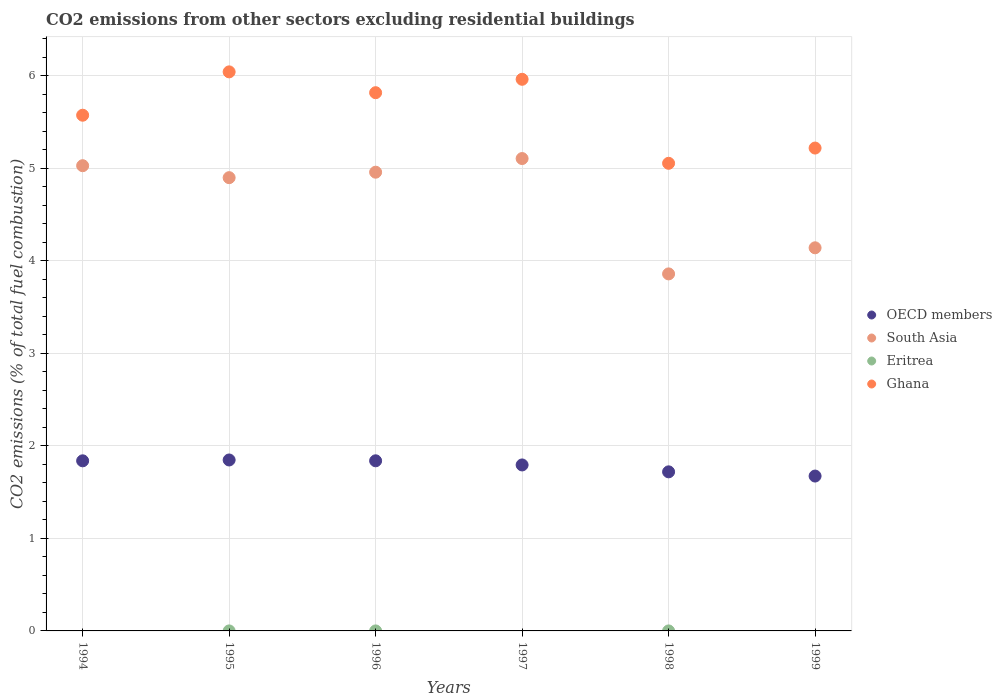Across all years, what is the maximum total CO2 emitted in South Asia?
Provide a short and direct response. 5.11. Across all years, what is the minimum total CO2 emitted in OECD members?
Offer a terse response. 1.67. What is the total total CO2 emitted in South Asia in the graph?
Offer a very short reply. 27.99. What is the difference between the total CO2 emitted in Ghana in 1997 and that in 1998?
Your answer should be very brief. 0.91. What is the difference between the total CO2 emitted in Ghana in 1995 and the total CO2 emitted in OECD members in 1996?
Offer a terse response. 4.2. What is the average total CO2 emitted in Ghana per year?
Ensure brevity in your answer.  5.61. In the year 1995, what is the difference between the total CO2 emitted in OECD members and total CO2 emitted in Eritrea?
Keep it short and to the point. 1.85. What is the ratio of the total CO2 emitted in OECD members in 1996 to that in 1997?
Your answer should be very brief. 1.02. Is the difference between the total CO2 emitted in OECD members in 1995 and 1998 greater than the difference between the total CO2 emitted in Eritrea in 1995 and 1998?
Ensure brevity in your answer.  Yes. What is the difference between the highest and the second highest total CO2 emitted in Ghana?
Your response must be concise. 0.08. What is the difference between the highest and the lowest total CO2 emitted in South Asia?
Your response must be concise. 1.25. Is it the case that in every year, the sum of the total CO2 emitted in Eritrea and total CO2 emitted in OECD members  is greater than the total CO2 emitted in Ghana?
Your answer should be compact. No. Does the total CO2 emitted in Eritrea monotonically increase over the years?
Offer a terse response. No. Is the total CO2 emitted in Eritrea strictly greater than the total CO2 emitted in Ghana over the years?
Your response must be concise. No. Is the total CO2 emitted in Eritrea strictly less than the total CO2 emitted in Ghana over the years?
Provide a short and direct response. Yes. What is the difference between two consecutive major ticks on the Y-axis?
Provide a short and direct response. 1. Are the values on the major ticks of Y-axis written in scientific E-notation?
Provide a succinct answer. No. Does the graph contain any zero values?
Ensure brevity in your answer.  Yes. What is the title of the graph?
Provide a short and direct response. CO2 emissions from other sectors excluding residential buildings. What is the label or title of the X-axis?
Your answer should be very brief. Years. What is the label or title of the Y-axis?
Keep it short and to the point. CO2 emissions (% of total fuel combustion). What is the CO2 emissions (% of total fuel combustion) of OECD members in 1994?
Provide a succinct answer. 1.84. What is the CO2 emissions (% of total fuel combustion) of South Asia in 1994?
Make the answer very short. 5.03. What is the CO2 emissions (% of total fuel combustion) of Ghana in 1994?
Your answer should be very brief. 5.57. What is the CO2 emissions (% of total fuel combustion) in OECD members in 1995?
Offer a very short reply. 1.85. What is the CO2 emissions (% of total fuel combustion) in South Asia in 1995?
Ensure brevity in your answer.  4.9. What is the CO2 emissions (% of total fuel combustion) of Eritrea in 1995?
Provide a succinct answer. 4.50577526227742e-16. What is the CO2 emissions (% of total fuel combustion) in Ghana in 1995?
Offer a very short reply. 6.04. What is the CO2 emissions (% of total fuel combustion) of OECD members in 1996?
Offer a terse response. 1.84. What is the CO2 emissions (% of total fuel combustion) of South Asia in 1996?
Your answer should be very brief. 4.96. What is the CO2 emissions (% of total fuel combustion) in Eritrea in 1996?
Your answer should be very brief. 0. What is the CO2 emissions (% of total fuel combustion) in Ghana in 1996?
Your answer should be very brief. 5.82. What is the CO2 emissions (% of total fuel combustion) in OECD members in 1997?
Ensure brevity in your answer.  1.79. What is the CO2 emissions (% of total fuel combustion) in South Asia in 1997?
Your answer should be compact. 5.11. What is the CO2 emissions (% of total fuel combustion) of Eritrea in 1997?
Your answer should be very brief. 0. What is the CO2 emissions (% of total fuel combustion) in Ghana in 1997?
Keep it short and to the point. 5.96. What is the CO2 emissions (% of total fuel combustion) of OECD members in 1998?
Keep it short and to the point. 1.72. What is the CO2 emissions (% of total fuel combustion) in South Asia in 1998?
Keep it short and to the point. 3.86. What is the CO2 emissions (% of total fuel combustion) of Eritrea in 1998?
Ensure brevity in your answer.  5.88041856263324e-16. What is the CO2 emissions (% of total fuel combustion) of Ghana in 1998?
Give a very brief answer. 5.05. What is the CO2 emissions (% of total fuel combustion) in OECD members in 1999?
Your response must be concise. 1.67. What is the CO2 emissions (% of total fuel combustion) of South Asia in 1999?
Offer a very short reply. 4.14. What is the CO2 emissions (% of total fuel combustion) in Ghana in 1999?
Ensure brevity in your answer.  5.22. Across all years, what is the maximum CO2 emissions (% of total fuel combustion) in OECD members?
Give a very brief answer. 1.85. Across all years, what is the maximum CO2 emissions (% of total fuel combustion) of South Asia?
Provide a succinct answer. 5.11. Across all years, what is the maximum CO2 emissions (% of total fuel combustion) of Eritrea?
Your answer should be very brief. 5.88041856263324e-16. Across all years, what is the maximum CO2 emissions (% of total fuel combustion) in Ghana?
Your answer should be compact. 6.04. Across all years, what is the minimum CO2 emissions (% of total fuel combustion) in OECD members?
Your response must be concise. 1.67. Across all years, what is the minimum CO2 emissions (% of total fuel combustion) of South Asia?
Give a very brief answer. 3.86. Across all years, what is the minimum CO2 emissions (% of total fuel combustion) of Ghana?
Offer a very short reply. 5.05. What is the total CO2 emissions (% of total fuel combustion) in OECD members in the graph?
Your answer should be compact. 10.71. What is the total CO2 emissions (% of total fuel combustion) of South Asia in the graph?
Provide a succinct answer. 27.99. What is the total CO2 emissions (% of total fuel combustion) in Ghana in the graph?
Offer a terse response. 33.67. What is the difference between the CO2 emissions (% of total fuel combustion) of OECD members in 1994 and that in 1995?
Provide a succinct answer. -0.01. What is the difference between the CO2 emissions (% of total fuel combustion) in South Asia in 1994 and that in 1995?
Your response must be concise. 0.13. What is the difference between the CO2 emissions (% of total fuel combustion) in Ghana in 1994 and that in 1995?
Make the answer very short. -0.47. What is the difference between the CO2 emissions (% of total fuel combustion) in OECD members in 1994 and that in 1996?
Your answer should be very brief. -0. What is the difference between the CO2 emissions (% of total fuel combustion) in South Asia in 1994 and that in 1996?
Offer a terse response. 0.07. What is the difference between the CO2 emissions (% of total fuel combustion) of Ghana in 1994 and that in 1996?
Provide a short and direct response. -0.24. What is the difference between the CO2 emissions (% of total fuel combustion) in OECD members in 1994 and that in 1997?
Provide a succinct answer. 0.04. What is the difference between the CO2 emissions (% of total fuel combustion) of South Asia in 1994 and that in 1997?
Your answer should be very brief. -0.08. What is the difference between the CO2 emissions (% of total fuel combustion) of Ghana in 1994 and that in 1997?
Offer a very short reply. -0.39. What is the difference between the CO2 emissions (% of total fuel combustion) of OECD members in 1994 and that in 1998?
Ensure brevity in your answer.  0.12. What is the difference between the CO2 emissions (% of total fuel combustion) in South Asia in 1994 and that in 1998?
Make the answer very short. 1.17. What is the difference between the CO2 emissions (% of total fuel combustion) of Ghana in 1994 and that in 1998?
Ensure brevity in your answer.  0.52. What is the difference between the CO2 emissions (% of total fuel combustion) of OECD members in 1994 and that in 1999?
Provide a short and direct response. 0.16. What is the difference between the CO2 emissions (% of total fuel combustion) of South Asia in 1994 and that in 1999?
Your answer should be compact. 0.89. What is the difference between the CO2 emissions (% of total fuel combustion) in Ghana in 1994 and that in 1999?
Provide a short and direct response. 0.35. What is the difference between the CO2 emissions (% of total fuel combustion) of OECD members in 1995 and that in 1996?
Your answer should be compact. 0.01. What is the difference between the CO2 emissions (% of total fuel combustion) in South Asia in 1995 and that in 1996?
Your answer should be very brief. -0.06. What is the difference between the CO2 emissions (% of total fuel combustion) of Ghana in 1995 and that in 1996?
Your answer should be very brief. 0.23. What is the difference between the CO2 emissions (% of total fuel combustion) of OECD members in 1995 and that in 1997?
Your answer should be compact. 0.05. What is the difference between the CO2 emissions (% of total fuel combustion) of South Asia in 1995 and that in 1997?
Keep it short and to the point. -0.21. What is the difference between the CO2 emissions (% of total fuel combustion) of Ghana in 1995 and that in 1997?
Give a very brief answer. 0.08. What is the difference between the CO2 emissions (% of total fuel combustion) in OECD members in 1995 and that in 1998?
Offer a very short reply. 0.13. What is the difference between the CO2 emissions (% of total fuel combustion) of South Asia in 1995 and that in 1998?
Offer a very short reply. 1.04. What is the difference between the CO2 emissions (% of total fuel combustion) of Eritrea in 1995 and that in 1998?
Give a very brief answer. -0. What is the difference between the CO2 emissions (% of total fuel combustion) of OECD members in 1995 and that in 1999?
Make the answer very short. 0.17. What is the difference between the CO2 emissions (% of total fuel combustion) in South Asia in 1995 and that in 1999?
Offer a very short reply. 0.76. What is the difference between the CO2 emissions (% of total fuel combustion) in Ghana in 1995 and that in 1999?
Ensure brevity in your answer.  0.82. What is the difference between the CO2 emissions (% of total fuel combustion) of OECD members in 1996 and that in 1997?
Provide a short and direct response. 0.04. What is the difference between the CO2 emissions (% of total fuel combustion) in South Asia in 1996 and that in 1997?
Make the answer very short. -0.15. What is the difference between the CO2 emissions (% of total fuel combustion) in Ghana in 1996 and that in 1997?
Keep it short and to the point. -0.14. What is the difference between the CO2 emissions (% of total fuel combustion) in OECD members in 1996 and that in 1998?
Your answer should be very brief. 0.12. What is the difference between the CO2 emissions (% of total fuel combustion) in South Asia in 1996 and that in 1998?
Keep it short and to the point. 1.1. What is the difference between the CO2 emissions (% of total fuel combustion) of Ghana in 1996 and that in 1998?
Make the answer very short. 0.76. What is the difference between the CO2 emissions (% of total fuel combustion) of OECD members in 1996 and that in 1999?
Offer a terse response. 0.16. What is the difference between the CO2 emissions (% of total fuel combustion) of South Asia in 1996 and that in 1999?
Offer a very short reply. 0.82. What is the difference between the CO2 emissions (% of total fuel combustion) of Ghana in 1996 and that in 1999?
Give a very brief answer. 0.6. What is the difference between the CO2 emissions (% of total fuel combustion) in OECD members in 1997 and that in 1998?
Your answer should be very brief. 0.07. What is the difference between the CO2 emissions (% of total fuel combustion) of South Asia in 1997 and that in 1998?
Provide a short and direct response. 1.25. What is the difference between the CO2 emissions (% of total fuel combustion) in Ghana in 1997 and that in 1998?
Keep it short and to the point. 0.91. What is the difference between the CO2 emissions (% of total fuel combustion) in OECD members in 1997 and that in 1999?
Give a very brief answer. 0.12. What is the difference between the CO2 emissions (% of total fuel combustion) of South Asia in 1997 and that in 1999?
Make the answer very short. 0.96. What is the difference between the CO2 emissions (% of total fuel combustion) in Ghana in 1997 and that in 1999?
Give a very brief answer. 0.74. What is the difference between the CO2 emissions (% of total fuel combustion) of OECD members in 1998 and that in 1999?
Provide a succinct answer. 0.05. What is the difference between the CO2 emissions (% of total fuel combustion) in South Asia in 1998 and that in 1999?
Give a very brief answer. -0.28. What is the difference between the CO2 emissions (% of total fuel combustion) of Ghana in 1998 and that in 1999?
Your response must be concise. -0.16. What is the difference between the CO2 emissions (% of total fuel combustion) of OECD members in 1994 and the CO2 emissions (% of total fuel combustion) of South Asia in 1995?
Offer a very short reply. -3.06. What is the difference between the CO2 emissions (% of total fuel combustion) in OECD members in 1994 and the CO2 emissions (% of total fuel combustion) in Eritrea in 1995?
Make the answer very short. 1.84. What is the difference between the CO2 emissions (% of total fuel combustion) of OECD members in 1994 and the CO2 emissions (% of total fuel combustion) of Ghana in 1995?
Offer a very short reply. -4.2. What is the difference between the CO2 emissions (% of total fuel combustion) of South Asia in 1994 and the CO2 emissions (% of total fuel combustion) of Eritrea in 1995?
Offer a terse response. 5.03. What is the difference between the CO2 emissions (% of total fuel combustion) in South Asia in 1994 and the CO2 emissions (% of total fuel combustion) in Ghana in 1995?
Your response must be concise. -1.01. What is the difference between the CO2 emissions (% of total fuel combustion) of OECD members in 1994 and the CO2 emissions (% of total fuel combustion) of South Asia in 1996?
Your answer should be very brief. -3.12. What is the difference between the CO2 emissions (% of total fuel combustion) in OECD members in 1994 and the CO2 emissions (% of total fuel combustion) in Ghana in 1996?
Give a very brief answer. -3.98. What is the difference between the CO2 emissions (% of total fuel combustion) in South Asia in 1994 and the CO2 emissions (% of total fuel combustion) in Ghana in 1996?
Your answer should be compact. -0.79. What is the difference between the CO2 emissions (% of total fuel combustion) of OECD members in 1994 and the CO2 emissions (% of total fuel combustion) of South Asia in 1997?
Provide a succinct answer. -3.27. What is the difference between the CO2 emissions (% of total fuel combustion) in OECD members in 1994 and the CO2 emissions (% of total fuel combustion) in Ghana in 1997?
Your response must be concise. -4.12. What is the difference between the CO2 emissions (% of total fuel combustion) in South Asia in 1994 and the CO2 emissions (% of total fuel combustion) in Ghana in 1997?
Your answer should be compact. -0.93. What is the difference between the CO2 emissions (% of total fuel combustion) of OECD members in 1994 and the CO2 emissions (% of total fuel combustion) of South Asia in 1998?
Make the answer very short. -2.02. What is the difference between the CO2 emissions (% of total fuel combustion) of OECD members in 1994 and the CO2 emissions (% of total fuel combustion) of Eritrea in 1998?
Ensure brevity in your answer.  1.84. What is the difference between the CO2 emissions (% of total fuel combustion) of OECD members in 1994 and the CO2 emissions (% of total fuel combustion) of Ghana in 1998?
Your answer should be very brief. -3.22. What is the difference between the CO2 emissions (% of total fuel combustion) of South Asia in 1994 and the CO2 emissions (% of total fuel combustion) of Eritrea in 1998?
Your answer should be compact. 5.03. What is the difference between the CO2 emissions (% of total fuel combustion) in South Asia in 1994 and the CO2 emissions (% of total fuel combustion) in Ghana in 1998?
Your answer should be very brief. -0.03. What is the difference between the CO2 emissions (% of total fuel combustion) of OECD members in 1994 and the CO2 emissions (% of total fuel combustion) of South Asia in 1999?
Your answer should be compact. -2.3. What is the difference between the CO2 emissions (% of total fuel combustion) of OECD members in 1994 and the CO2 emissions (% of total fuel combustion) of Ghana in 1999?
Offer a terse response. -3.38. What is the difference between the CO2 emissions (% of total fuel combustion) of South Asia in 1994 and the CO2 emissions (% of total fuel combustion) of Ghana in 1999?
Make the answer very short. -0.19. What is the difference between the CO2 emissions (% of total fuel combustion) in OECD members in 1995 and the CO2 emissions (% of total fuel combustion) in South Asia in 1996?
Provide a succinct answer. -3.11. What is the difference between the CO2 emissions (% of total fuel combustion) in OECD members in 1995 and the CO2 emissions (% of total fuel combustion) in Ghana in 1996?
Provide a succinct answer. -3.97. What is the difference between the CO2 emissions (% of total fuel combustion) in South Asia in 1995 and the CO2 emissions (% of total fuel combustion) in Ghana in 1996?
Offer a very short reply. -0.92. What is the difference between the CO2 emissions (% of total fuel combustion) of Eritrea in 1995 and the CO2 emissions (% of total fuel combustion) of Ghana in 1996?
Your answer should be compact. -5.82. What is the difference between the CO2 emissions (% of total fuel combustion) of OECD members in 1995 and the CO2 emissions (% of total fuel combustion) of South Asia in 1997?
Your answer should be very brief. -3.26. What is the difference between the CO2 emissions (% of total fuel combustion) in OECD members in 1995 and the CO2 emissions (% of total fuel combustion) in Ghana in 1997?
Ensure brevity in your answer.  -4.11. What is the difference between the CO2 emissions (% of total fuel combustion) in South Asia in 1995 and the CO2 emissions (% of total fuel combustion) in Ghana in 1997?
Make the answer very short. -1.06. What is the difference between the CO2 emissions (% of total fuel combustion) of Eritrea in 1995 and the CO2 emissions (% of total fuel combustion) of Ghana in 1997?
Your response must be concise. -5.96. What is the difference between the CO2 emissions (% of total fuel combustion) in OECD members in 1995 and the CO2 emissions (% of total fuel combustion) in South Asia in 1998?
Give a very brief answer. -2.01. What is the difference between the CO2 emissions (% of total fuel combustion) in OECD members in 1995 and the CO2 emissions (% of total fuel combustion) in Eritrea in 1998?
Give a very brief answer. 1.85. What is the difference between the CO2 emissions (% of total fuel combustion) in OECD members in 1995 and the CO2 emissions (% of total fuel combustion) in Ghana in 1998?
Ensure brevity in your answer.  -3.21. What is the difference between the CO2 emissions (% of total fuel combustion) of South Asia in 1995 and the CO2 emissions (% of total fuel combustion) of Eritrea in 1998?
Your answer should be compact. 4.9. What is the difference between the CO2 emissions (% of total fuel combustion) in South Asia in 1995 and the CO2 emissions (% of total fuel combustion) in Ghana in 1998?
Offer a very short reply. -0.16. What is the difference between the CO2 emissions (% of total fuel combustion) in Eritrea in 1995 and the CO2 emissions (% of total fuel combustion) in Ghana in 1998?
Offer a terse response. -5.05. What is the difference between the CO2 emissions (% of total fuel combustion) of OECD members in 1995 and the CO2 emissions (% of total fuel combustion) of South Asia in 1999?
Offer a very short reply. -2.29. What is the difference between the CO2 emissions (% of total fuel combustion) of OECD members in 1995 and the CO2 emissions (% of total fuel combustion) of Ghana in 1999?
Keep it short and to the point. -3.37. What is the difference between the CO2 emissions (% of total fuel combustion) in South Asia in 1995 and the CO2 emissions (% of total fuel combustion) in Ghana in 1999?
Keep it short and to the point. -0.32. What is the difference between the CO2 emissions (% of total fuel combustion) in Eritrea in 1995 and the CO2 emissions (% of total fuel combustion) in Ghana in 1999?
Provide a succinct answer. -5.22. What is the difference between the CO2 emissions (% of total fuel combustion) in OECD members in 1996 and the CO2 emissions (% of total fuel combustion) in South Asia in 1997?
Offer a terse response. -3.27. What is the difference between the CO2 emissions (% of total fuel combustion) in OECD members in 1996 and the CO2 emissions (% of total fuel combustion) in Ghana in 1997?
Your response must be concise. -4.12. What is the difference between the CO2 emissions (% of total fuel combustion) in South Asia in 1996 and the CO2 emissions (% of total fuel combustion) in Ghana in 1997?
Give a very brief answer. -1. What is the difference between the CO2 emissions (% of total fuel combustion) of OECD members in 1996 and the CO2 emissions (% of total fuel combustion) of South Asia in 1998?
Keep it short and to the point. -2.02. What is the difference between the CO2 emissions (% of total fuel combustion) in OECD members in 1996 and the CO2 emissions (% of total fuel combustion) in Eritrea in 1998?
Provide a short and direct response. 1.84. What is the difference between the CO2 emissions (% of total fuel combustion) in OECD members in 1996 and the CO2 emissions (% of total fuel combustion) in Ghana in 1998?
Ensure brevity in your answer.  -3.22. What is the difference between the CO2 emissions (% of total fuel combustion) in South Asia in 1996 and the CO2 emissions (% of total fuel combustion) in Eritrea in 1998?
Your answer should be very brief. 4.96. What is the difference between the CO2 emissions (% of total fuel combustion) in South Asia in 1996 and the CO2 emissions (% of total fuel combustion) in Ghana in 1998?
Ensure brevity in your answer.  -0.1. What is the difference between the CO2 emissions (% of total fuel combustion) of OECD members in 1996 and the CO2 emissions (% of total fuel combustion) of South Asia in 1999?
Your answer should be very brief. -2.3. What is the difference between the CO2 emissions (% of total fuel combustion) in OECD members in 1996 and the CO2 emissions (% of total fuel combustion) in Ghana in 1999?
Ensure brevity in your answer.  -3.38. What is the difference between the CO2 emissions (% of total fuel combustion) of South Asia in 1996 and the CO2 emissions (% of total fuel combustion) of Ghana in 1999?
Make the answer very short. -0.26. What is the difference between the CO2 emissions (% of total fuel combustion) in OECD members in 1997 and the CO2 emissions (% of total fuel combustion) in South Asia in 1998?
Your answer should be very brief. -2.06. What is the difference between the CO2 emissions (% of total fuel combustion) of OECD members in 1997 and the CO2 emissions (% of total fuel combustion) of Eritrea in 1998?
Keep it short and to the point. 1.79. What is the difference between the CO2 emissions (% of total fuel combustion) of OECD members in 1997 and the CO2 emissions (% of total fuel combustion) of Ghana in 1998?
Your response must be concise. -3.26. What is the difference between the CO2 emissions (% of total fuel combustion) of South Asia in 1997 and the CO2 emissions (% of total fuel combustion) of Eritrea in 1998?
Your answer should be compact. 5.11. What is the difference between the CO2 emissions (% of total fuel combustion) in South Asia in 1997 and the CO2 emissions (% of total fuel combustion) in Ghana in 1998?
Your answer should be compact. 0.05. What is the difference between the CO2 emissions (% of total fuel combustion) of OECD members in 1997 and the CO2 emissions (% of total fuel combustion) of South Asia in 1999?
Provide a short and direct response. -2.35. What is the difference between the CO2 emissions (% of total fuel combustion) of OECD members in 1997 and the CO2 emissions (% of total fuel combustion) of Ghana in 1999?
Provide a succinct answer. -3.42. What is the difference between the CO2 emissions (% of total fuel combustion) of South Asia in 1997 and the CO2 emissions (% of total fuel combustion) of Ghana in 1999?
Your answer should be compact. -0.11. What is the difference between the CO2 emissions (% of total fuel combustion) in OECD members in 1998 and the CO2 emissions (% of total fuel combustion) in South Asia in 1999?
Provide a succinct answer. -2.42. What is the difference between the CO2 emissions (% of total fuel combustion) of OECD members in 1998 and the CO2 emissions (% of total fuel combustion) of Ghana in 1999?
Provide a short and direct response. -3.5. What is the difference between the CO2 emissions (% of total fuel combustion) in South Asia in 1998 and the CO2 emissions (% of total fuel combustion) in Ghana in 1999?
Your answer should be compact. -1.36. What is the difference between the CO2 emissions (% of total fuel combustion) of Eritrea in 1998 and the CO2 emissions (% of total fuel combustion) of Ghana in 1999?
Give a very brief answer. -5.22. What is the average CO2 emissions (% of total fuel combustion) of OECD members per year?
Make the answer very short. 1.79. What is the average CO2 emissions (% of total fuel combustion) of South Asia per year?
Keep it short and to the point. 4.67. What is the average CO2 emissions (% of total fuel combustion) in Ghana per year?
Keep it short and to the point. 5.61. In the year 1994, what is the difference between the CO2 emissions (% of total fuel combustion) in OECD members and CO2 emissions (% of total fuel combustion) in South Asia?
Your answer should be compact. -3.19. In the year 1994, what is the difference between the CO2 emissions (% of total fuel combustion) in OECD members and CO2 emissions (% of total fuel combustion) in Ghana?
Your answer should be very brief. -3.74. In the year 1994, what is the difference between the CO2 emissions (% of total fuel combustion) of South Asia and CO2 emissions (% of total fuel combustion) of Ghana?
Keep it short and to the point. -0.55. In the year 1995, what is the difference between the CO2 emissions (% of total fuel combustion) in OECD members and CO2 emissions (% of total fuel combustion) in South Asia?
Ensure brevity in your answer.  -3.05. In the year 1995, what is the difference between the CO2 emissions (% of total fuel combustion) of OECD members and CO2 emissions (% of total fuel combustion) of Eritrea?
Make the answer very short. 1.85. In the year 1995, what is the difference between the CO2 emissions (% of total fuel combustion) of OECD members and CO2 emissions (% of total fuel combustion) of Ghana?
Keep it short and to the point. -4.19. In the year 1995, what is the difference between the CO2 emissions (% of total fuel combustion) of South Asia and CO2 emissions (% of total fuel combustion) of Eritrea?
Ensure brevity in your answer.  4.9. In the year 1995, what is the difference between the CO2 emissions (% of total fuel combustion) in South Asia and CO2 emissions (% of total fuel combustion) in Ghana?
Your response must be concise. -1.14. In the year 1995, what is the difference between the CO2 emissions (% of total fuel combustion) in Eritrea and CO2 emissions (% of total fuel combustion) in Ghana?
Ensure brevity in your answer.  -6.04. In the year 1996, what is the difference between the CO2 emissions (% of total fuel combustion) of OECD members and CO2 emissions (% of total fuel combustion) of South Asia?
Give a very brief answer. -3.12. In the year 1996, what is the difference between the CO2 emissions (% of total fuel combustion) of OECD members and CO2 emissions (% of total fuel combustion) of Ghana?
Ensure brevity in your answer.  -3.98. In the year 1996, what is the difference between the CO2 emissions (% of total fuel combustion) in South Asia and CO2 emissions (% of total fuel combustion) in Ghana?
Keep it short and to the point. -0.86. In the year 1997, what is the difference between the CO2 emissions (% of total fuel combustion) in OECD members and CO2 emissions (% of total fuel combustion) in South Asia?
Offer a terse response. -3.31. In the year 1997, what is the difference between the CO2 emissions (% of total fuel combustion) in OECD members and CO2 emissions (% of total fuel combustion) in Ghana?
Provide a short and direct response. -4.17. In the year 1997, what is the difference between the CO2 emissions (% of total fuel combustion) of South Asia and CO2 emissions (% of total fuel combustion) of Ghana?
Your response must be concise. -0.86. In the year 1998, what is the difference between the CO2 emissions (% of total fuel combustion) in OECD members and CO2 emissions (% of total fuel combustion) in South Asia?
Offer a terse response. -2.14. In the year 1998, what is the difference between the CO2 emissions (% of total fuel combustion) in OECD members and CO2 emissions (% of total fuel combustion) in Eritrea?
Provide a short and direct response. 1.72. In the year 1998, what is the difference between the CO2 emissions (% of total fuel combustion) in OECD members and CO2 emissions (% of total fuel combustion) in Ghana?
Ensure brevity in your answer.  -3.33. In the year 1998, what is the difference between the CO2 emissions (% of total fuel combustion) of South Asia and CO2 emissions (% of total fuel combustion) of Eritrea?
Offer a terse response. 3.86. In the year 1998, what is the difference between the CO2 emissions (% of total fuel combustion) in South Asia and CO2 emissions (% of total fuel combustion) in Ghana?
Provide a short and direct response. -1.2. In the year 1998, what is the difference between the CO2 emissions (% of total fuel combustion) in Eritrea and CO2 emissions (% of total fuel combustion) in Ghana?
Your answer should be very brief. -5.05. In the year 1999, what is the difference between the CO2 emissions (% of total fuel combustion) of OECD members and CO2 emissions (% of total fuel combustion) of South Asia?
Provide a short and direct response. -2.47. In the year 1999, what is the difference between the CO2 emissions (% of total fuel combustion) of OECD members and CO2 emissions (% of total fuel combustion) of Ghana?
Your response must be concise. -3.54. In the year 1999, what is the difference between the CO2 emissions (% of total fuel combustion) in South Asia and CO2 emissions (% of total fuel combustion) in Ghana?
Keep it short and to the point. -1.08. What is the ratio of the CO2 emissions (% of total fuel combustion) of South Asia in 1994 to that in 1995?
Keep it short and to the point. 1.03. What is the ratio of the CO2 emissions (% of total fuel combustion) of Ghana in 1994 to that in 1995?
Ensure brevity in your answer.  0.92. What is the ratio of the CO2 emissions (% of total fuel combustion) of OECD members in 1994 to that in 1996?
Give a very brief answer. 1. What is the ratio of the CO2 emissions (% of total fuel combustion) of South Asia in 1994 to that in 1996?
Your response must be concise. 1.01. What is the ratio of the CO2 emissions (% of total fuel combustion) of Ghana in 1994 to that in 1996?
Offer a very short reply. 0.96. What is the ratio of the CO2 emissions (% of total fuel combustion) in OECD members in 1994 to that in 1997?
Offer a very short reply. 1.02. What is the ratio of the CO2 emissions (% of total fuel combustion) in South Asia in 1994 to that in 1997?
Provide a succinct answer. 0.98. What is the ratio of the CO2 emissions (% of total fuel combustion) in Ghana in 1994 to that in 1997?
Your answer should be compact. 0.93. What is the ratio of the CO2 emissions (% of total fuel combustion) in OECD members in 1994 to that in 1998?
Give a very brief answer. 1.07. What is the ratio of the CO2 emissions (% of total fuel combustion) of South Asia in 1994 to that in 1998?
Your answer should be very brief. 1.3. What is the ratio of the CO2 emissions (% of total fuel combustion) in Ghana in 1994 to that in 1998?
Ensure brevity in your answer.  1.1. What is the ratio of the CO2 emissions (% of total fuel combustion) of OECD members in 1994 to that in 1999?
Make the answer very short. 1.1. What is the ratio of the CO2 emissions (% of total fuel combustion) of South Asia in 1994 to that in 1999?
Your response must be concise. 1.21. What is the ratio of the CO2 emissions (% of total fuel combustion) in Ghana in 1994 to that in 1999?
Provide a short and direct response. 1.07. What is the ratio of the CO2 emissions (% of total fuel combustion) in OECD members in 1995 to that in 1996?
Provide a short and direct response. 1. What is the ratio of the CO2 emissions (% of total fuel combustion) in South Asia in 1995 to that in 1996?
Offer a terse response. 0.99. What is the ratio of the CO2 emissions (% of total fuel combustion) of Ghana in 1995 to that in 1996?
Your response must be concise. 1.04. What is the ratio of the CO2 emissions (% of total fuel combustion) of OECD members in 1995 to that in 1997?
Offer a very short reply. 1.03. What is the ratio of the CO2 emissions (% of total fuel combustion) in South Asia in 1995 to that in 1997?
Make the answer very short. 0.96. What is the ratio of the CO2 emissions (% of total fuel combustion) of Ghana in 1995 to that in 1997?
Your response must be concise. 1.01. What is the ratio of the CO2 emissions (% of total fuel combustion) of OECD members in 1995 to that in 1998?
Keep it short and to the point. 1.07. What is the ratio of the CO2 emissions (% of total fuel combustion) of South Asia in 1995 to that in 1998?
Provide a succinct answer. 1.27. What is the ratio of the CO2 emissions (% of total fuel combustion) in Eritrea in 1995 to that in 1998?
Your answer should be very brief. 0.77. What is the ratio of the CO2 emissions (% of total fuel combustion) of Ghana in 1995 to that in 1998?
Your answer should be compact. 1.2. What is the ratio of the CO2 emissions (% of total fuel combustion) in OECD members in 1995 to that in 1999?
Give a very brief answer. 1.1. What is the ratio of the CO2 emissions (% of total fuel combustion) of South Asia in 1995 to that in 1999?
Keep it short and to the point. 1.18. What is the ratio of the CO2 emissions (% of total fuel combustion) in Ghana in 1995 to that in 1999?
Your answer should be very brief. 1.16. What is the ratio of the CO2 emissions (% of total fuel combustion) in OECD members in 1996 to that in 1997?
Keep it short and to the point. 1.02. What is the ratio of the CO2 emissions (% of total fuel combustion) in South Asia in 1996 to that in 1997?
Your answer should be compact. 0.97. What is the ratio of the CO2 emissions (% of total fuel combustion) of Ghana in 1996 to that in 1997?
Provide a succinct answer. 0.98. What is the ratio of the CO2 emissions (% of total fuel combustion) of OECD members in 1996 to that in 1998?
Offer a very short reply. 1.07. What is the ratio of the CO2 emissions (% of total fuel combustion) of South Asia in 1996 to that in 1998?
Make the answer very short. 1.28. What is the ratio of the CO2 emissions (% of total fuel combustion) of Ghana in 1996 to that in 1998?
Offer a terse response. 1.15. What is the ratio of the CO2 emissions (% of total fuel combustion) of OECD members in 1996 to that in 1999?
Give a very brief answer. 1.1. What is the ratio of the CO2 emissions (% of total fuel combustion) of South Asia in 1996 to that in 1999?
Offer a terse response. 1.2. What is the ratio of the CO2 emissions (% of total fuel combustion) of Ghana in 1996 to that in 1999?
Provide a short and direct response. 1.11. What is the ratio of the CO2 emissions (% of total fuel combustion) in OECD members in 1997 to that in 1998?
Your response must be concise. 1.04. What is the ratio of the CO2 emissions (% of total fuel combustion) in South Asia in 1997 to that in 1998?
Offer a very short reply. 1.32. What is the ratio of the CO2 emissions (% of total fuel combustion) of Ghana in 1997 to that in 1998?
Offer a terse response. 1.18. What is the ratio of the CO2 emissions (% of total fuel combustion) in OECD members in 1997 to that in 1999?
Offer a terse response. 1.07. What is the ratio of the CO2 emissions (% of total fuel combustion) in South Asia in 1997 to that in 1999?
Give a very brief answer. 1.23. What is the ratio of the CO2 emissions (% of total fuel combustion) in Ghana in 1997 to that in 1999?
Your response must be concise. 1.14. What is the ratio of the CO2 emissions (% of total fuel combustion) of OECD members in 1998 to that in 1999?
Your response must be concise. 1.03. What is the ratio of the CO2 emissions (% of total fuel combustion) of South Asia in 1998 to that in 1999?
Give a very brief answer. 0.93. What is the ratio of the CO2 emissions (% of total fuel combustion) in Ghana in 1998 to that in 1999?
Offer a very short reply. 0.97. What is the difference between the highest and the second highest CO2 emissions (% of total fuel combustion) of OECD members?
Your answer should be compact. 0.01. What is the difference between the highest and the second highest CO2 emissions (% of total fuel combustion) in South Asia?
Give a very brief answer. 0.08. What is the difference between the highest and the second highest CO2 emissions (% of total fuel combustion) of Ghana?
Your response must be concise. 0.08. What is the difference between the highest and the lowest CO2 emissions (% of total fuel combustion) of OECD members?
Offer a very short reply. 0.17. What is the difference between the highest and the lowest CO2 emissions (% of total fuel combustion) of South Asia?
Give a very brief answer. 1.25. 